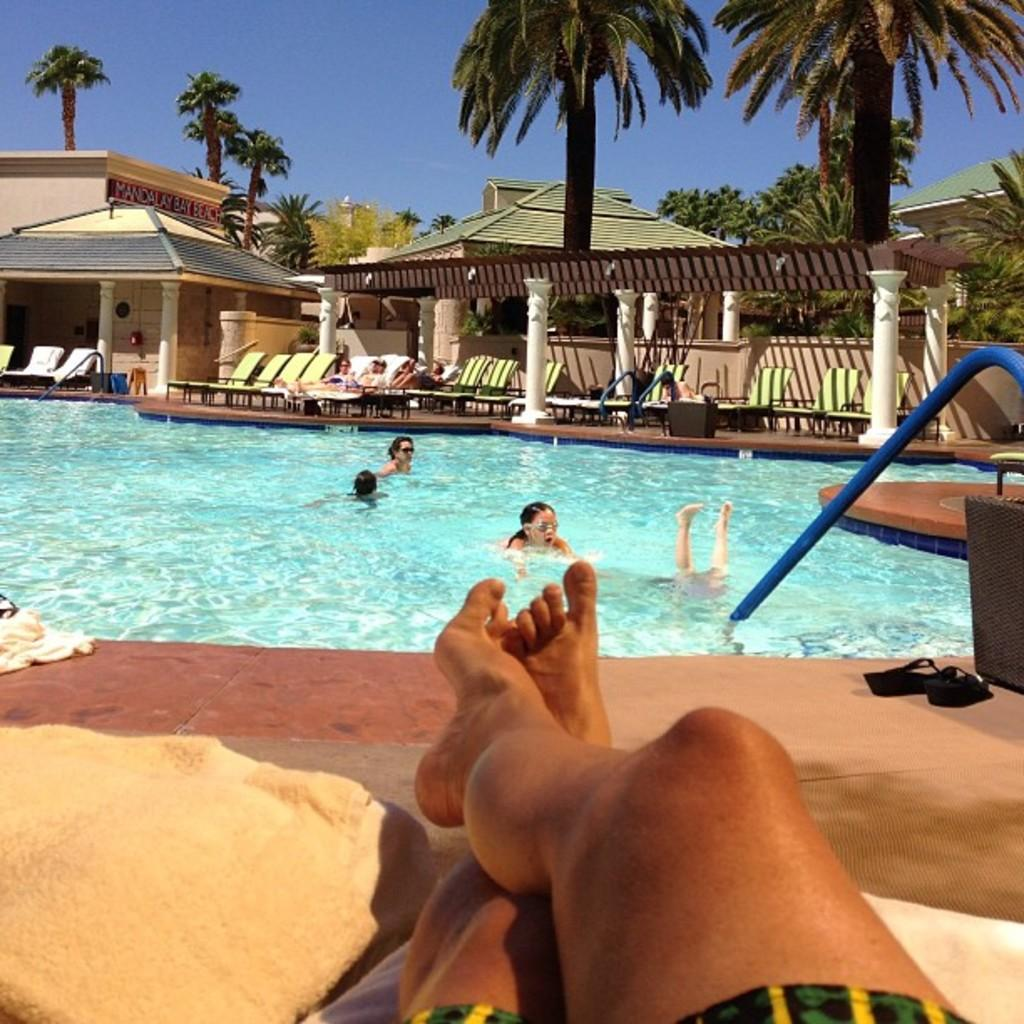Who or what can be seen in the image? There are people visible in the image. What is the primary element in the image? There is water in the image. What can be seen in the background of the image? In the background, there are people, chairs, pillars, houses, trees, and the sky. What type of base is being used by the doctor during the birth scene in the image? There is no base, doctor, or birth scene present in the image. 